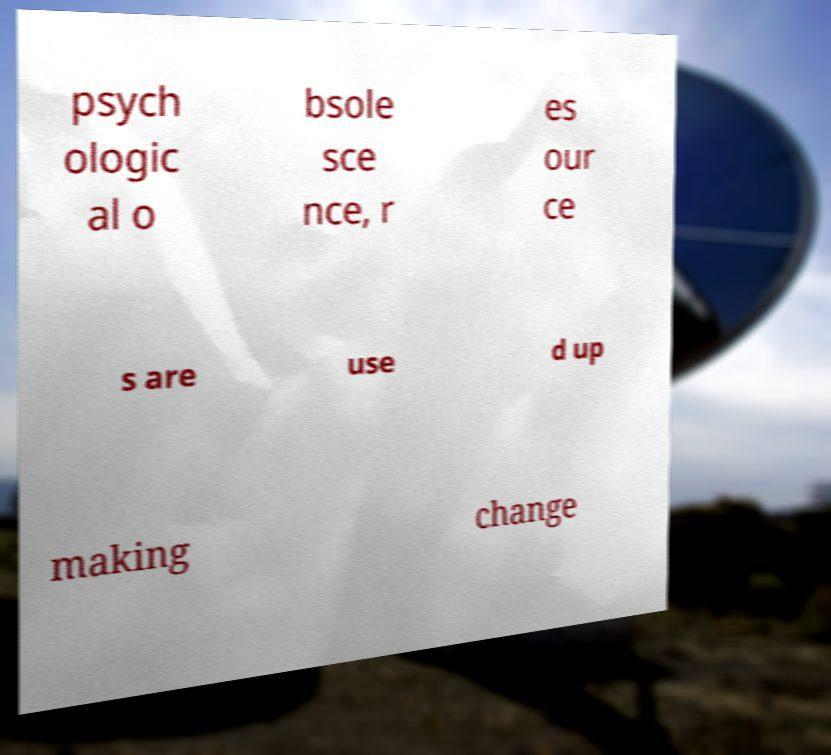Can you accurately transcribe the text from the provided image for me? psych ologic al o bsole sce nce, r es our ce s are use d up making change 